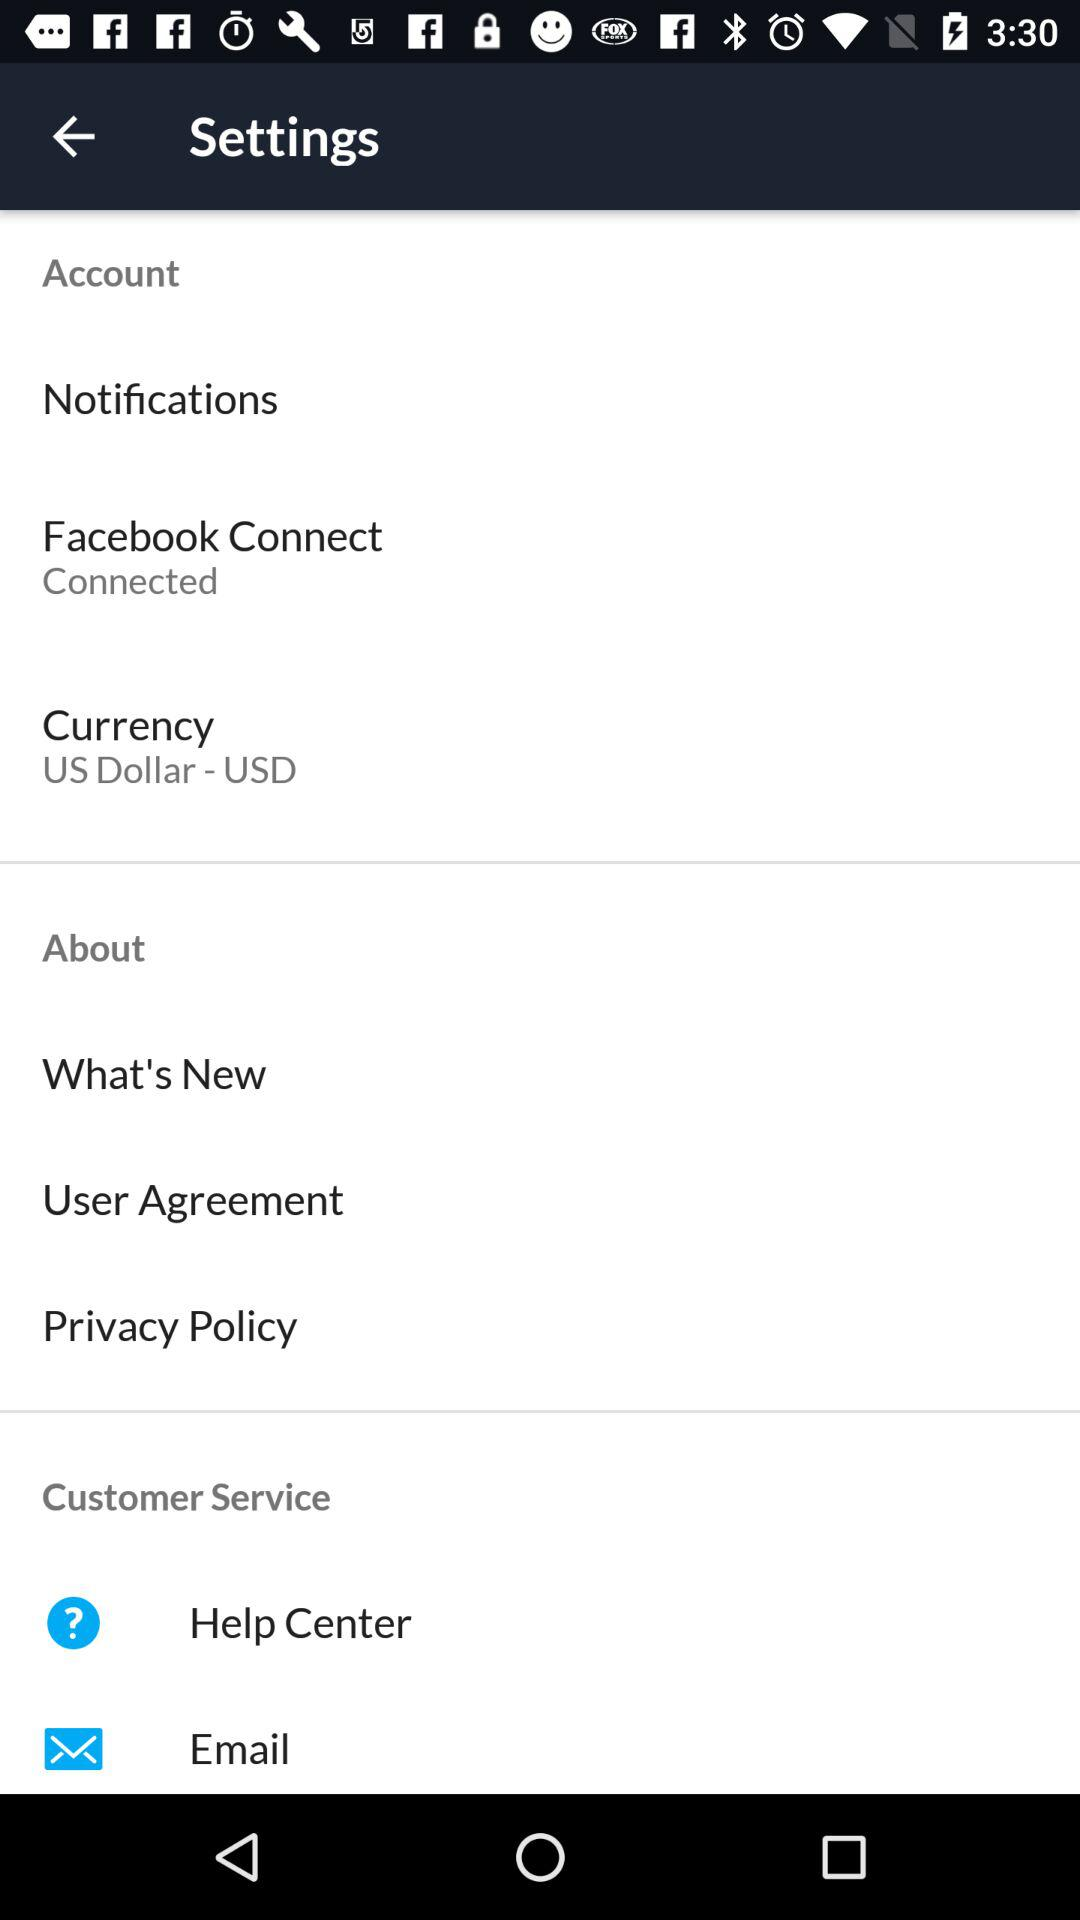How many items in the settings menu have a connected status?
Answer the question using a single word or phrase. 1 